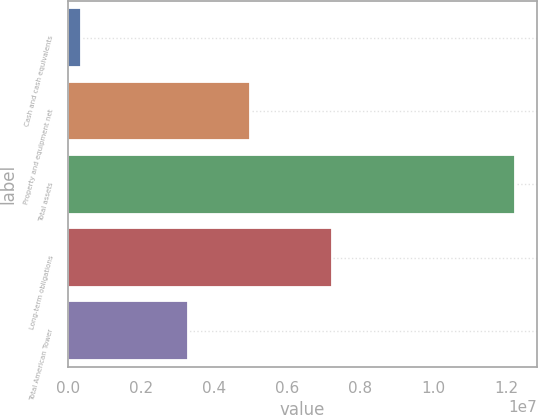<chart> <loc_0><loc_0><loc_500><loc_500><bar_chart><fcel>Cash and cash equivalents<fcel>Property and equipment net<fcel>Total assets<fcel>Long-term obligations<fcel>Total American Tower<nl><fcel>372406<fcel>4.98172e+06<fcel>1.22424e+07<fcel>7.23631e+06<fcel>3.28722e+06<nl></chart> 